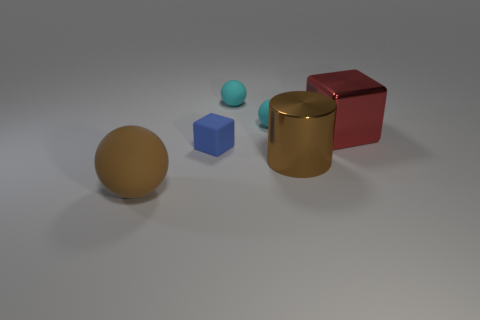How many small rubber things are to the left of the big brown thing to the right of the tiny matte object in front of the metallic block? 3 